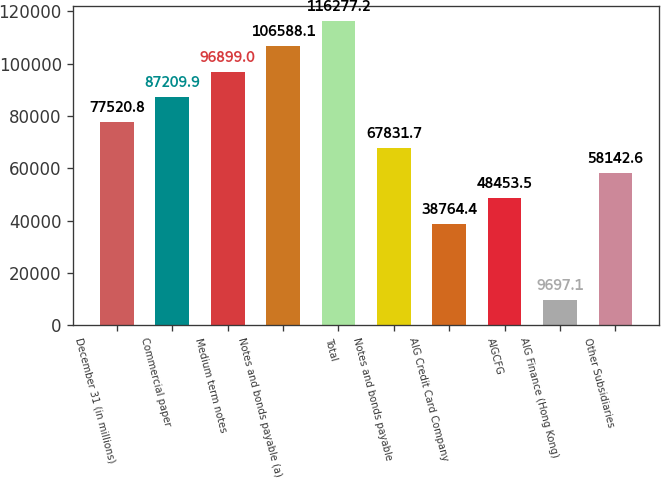<chart> <loc_0><loc_0><loc_500><loc_500><bar_chart><fcel>December 31 (in millions)<fcel>Commercial paper<fcel>Medium term notes<fcel>Notes and bonds payable (a)<fcel>Total<fcel>Notes and bonds payable<fcel>AIG Credit Card Company<fcel>AIGCFG<fcel>AIG Finance (Hong Kong)<fcel>Other Subsidiaries<nl><fcel>77520.8<fcel>87209.9<fcel>96899<fcel>106588<fcel>116277<fcel>67831.7<fcel>38764.4<fcel>48453.5<fcel>9697.1<fcel>58142.6<nl></chart> 